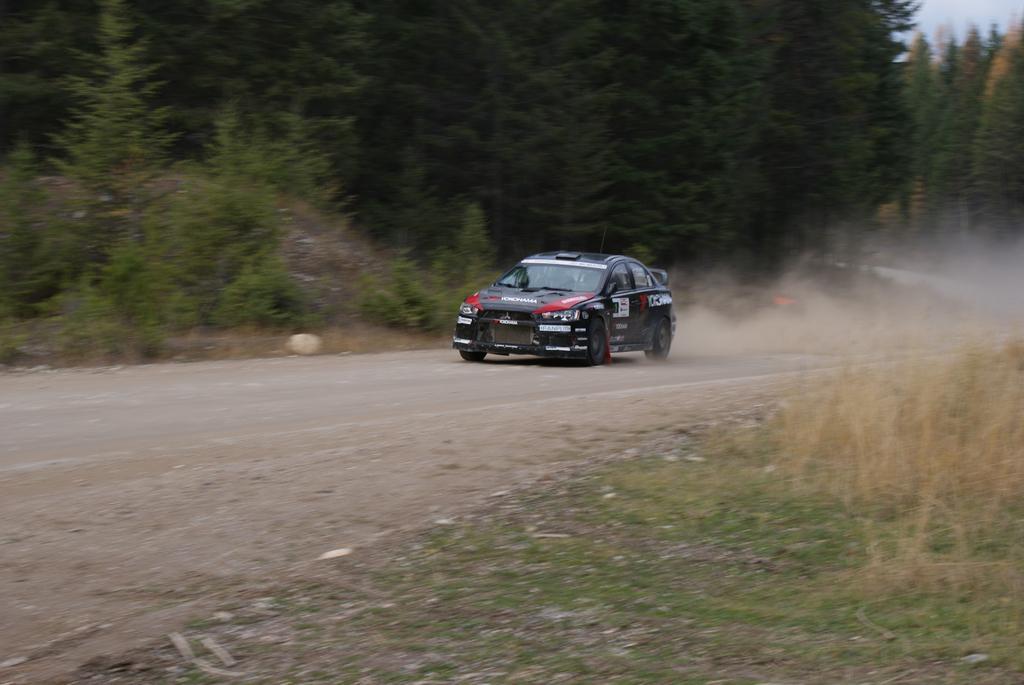Can you describe this image briefly? In this image I can see a vehicle on the road. On the left side I can see the trees. I can also see the sky. 